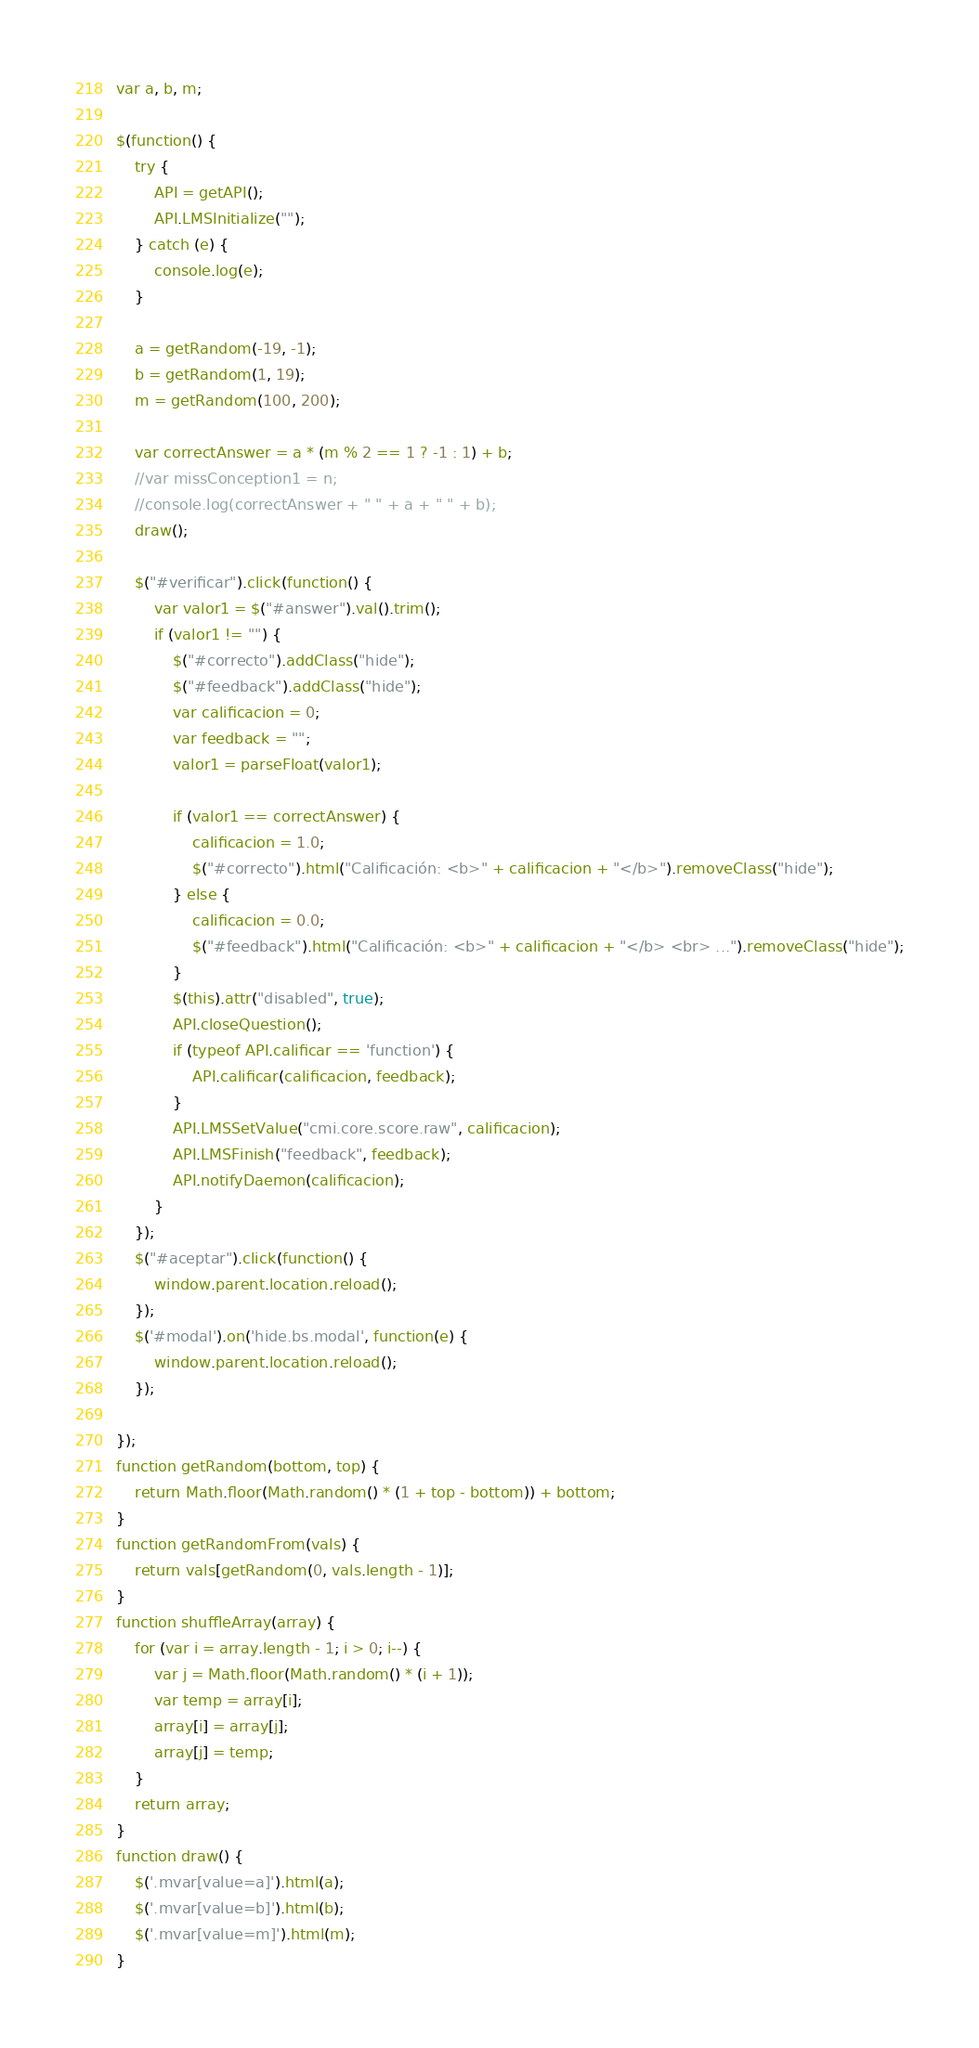Convert code to text. <code><loc_0><loc_0><loc_500><loc_500><_JavaScript_>var a, b, m;

$(function() {
    try {
        API = getAPI();
        API.LMSInitialize("");
    } catch (e) {
        console.log(e);
    }

    a = getRandom(-19, -1);
    b = getRandom(1, 19);
    m = getRandom(100, 200);

    var correctAnswer = a * (m % 2 == 1 ? -1 : 1) + b;
    //var missConception1 = n;
    //console.log(correctAnswer + " " + a + " " + b);
    draw();

    $("#verificar").click(function() {
        var valor1 = $("#answer").val().trim();
        if (valor1 != "") {
            $("#correcto").addClass("hide");
            $("#feedback").addClass("hide");
            var calificacion = 0;
            var feedback = "";
            valor1 = parseFloat(valor1);

            if (valor1 == correctAnswer) {
                calificacion = 1.0;
                $("#correcto").html("Calificación: <b>" + calificacion + "</b>").removeClass("hide");
            } else {
                calificacion = 0.0;
                $("#feedback").html("Calificación: <b>" + calificacion + "</b> <br> ...").removeClass("hide");
            }
            $(this).attr("disabled", true);
            API.closeQuestion();
            if (typeof API.calificar == 'function') {
                API.calificar(calificacion, feedback);
            }
            API.LMSSetValue("cmi.core.score.raw", calificacion);
            API.LMSFinish("feedback", feedback);
            API.notifyDaemon(calificacion);
        }
    });
    $("#aceptar").click(function() {
        window.parent.location.reload();
    });
    $('#modal').on('hide.bs.modal', function(e) {
        window.parent.location.reload();
    });

});
function getRandom(bottom, top) {
    return Math.floor(Math.random() * (1 + top - bottom)) + bottom;
}
function getRandomFrom(vals) {
    return vals[getRandom(0, vals.length - 1)];
}
function shuffleArray(array) {
    for (var i = array.length - 1; i > 0; i--) {
        var j = Math.floor(Math.random() * (i + 1));
        var temp = array[i];
        array[i] = array[j];
        array[j] = temp;
    }
    return array;
}
function draw() {
    $('.mvar[value=a]').html(a);
    $('.mvar[value=b]').html(b);
    $('.mvar[value=m]').html(m);
}
</code> 